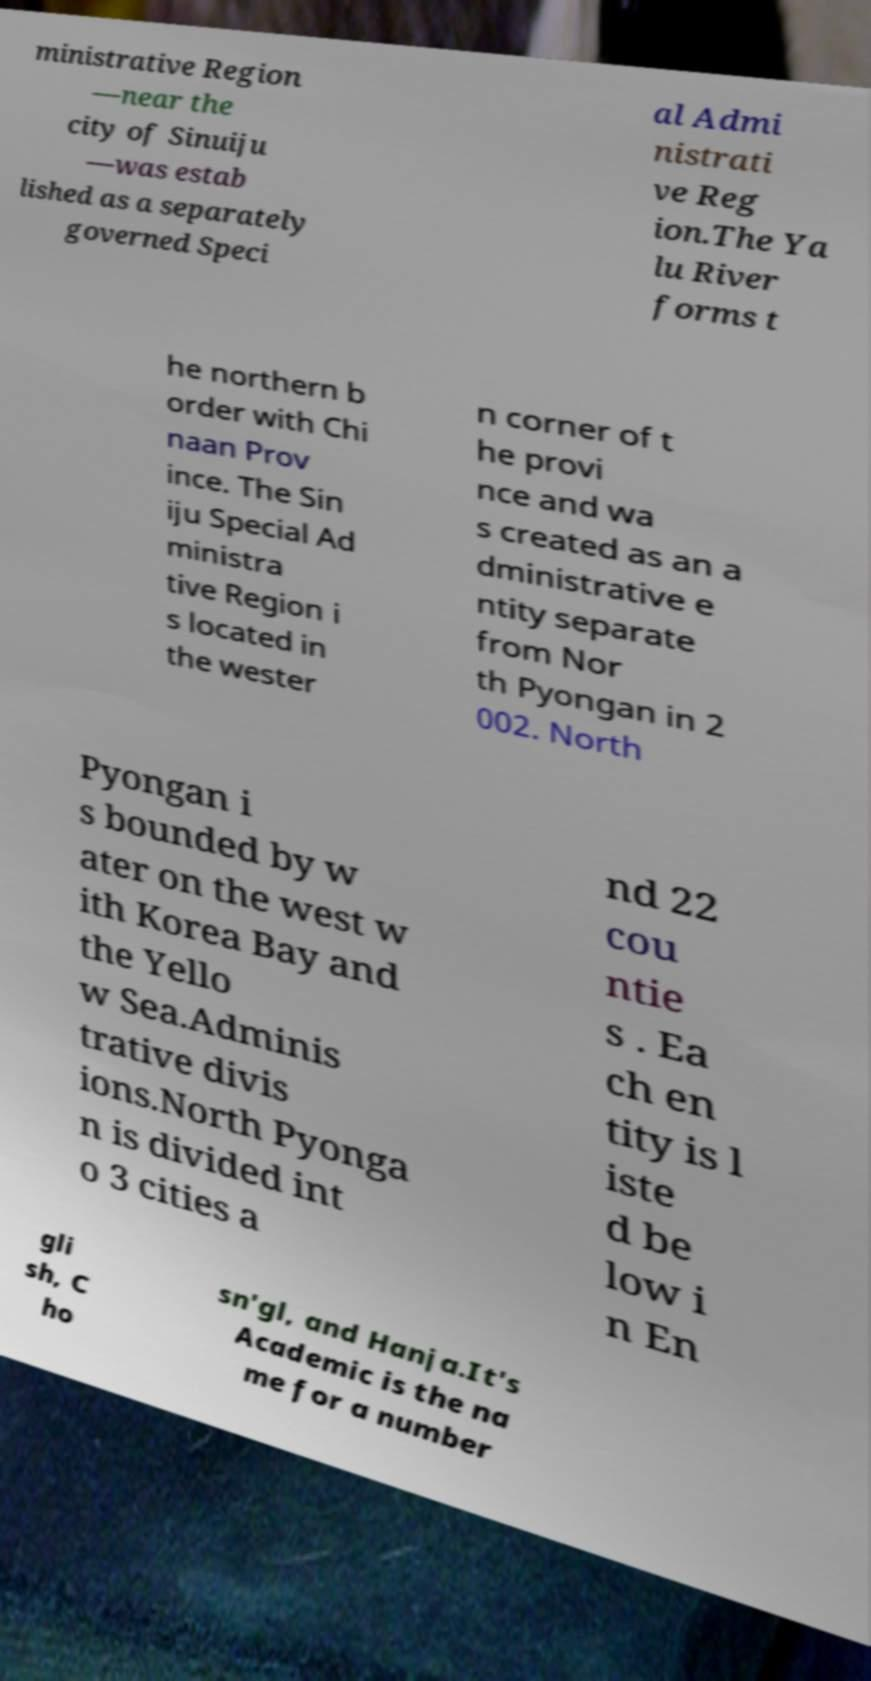For documentation purposes, I need the text within this image transcribed. Could you provide that? ministrative Region —near the city of Sinuiju —was estab lished as a separately governed Speci al Admi nistrati ve Reg ion.The Ya lu River forms t he northern b order with Chi naan Prov ince. The Sin iju Special Ad ministra tive Region i s located in the wester n corner of t he provi nce and wa s created as an a dministrative e ntity separate from Nor th Pyongan in 2 002. North Pyongan i s bounded by w ater on the west w ith Korea Bay and the Yello w Sea.Adminis trative divis ions.North Pyonga n is divided int o 3 cities a nd 22 cou ntie s . Ea ch en tity is l iste d be low i n En gli sh, C ho sn'gl, and Hanja.It's Academic is the na me for a number 